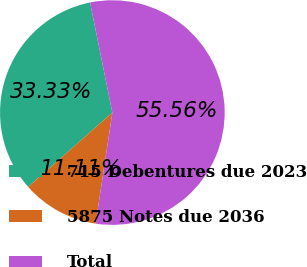Convert chart to OTSL. <chart><loc_0><loc_0><loc_500><loc_500><pie_chart><fcel>715 Debentures due 2023<fcel>5875 Notes due 2036<fcel>Total<nl><fcel>33.33%<fcel>11.11%<fcel>55.56%<nl></chart> 